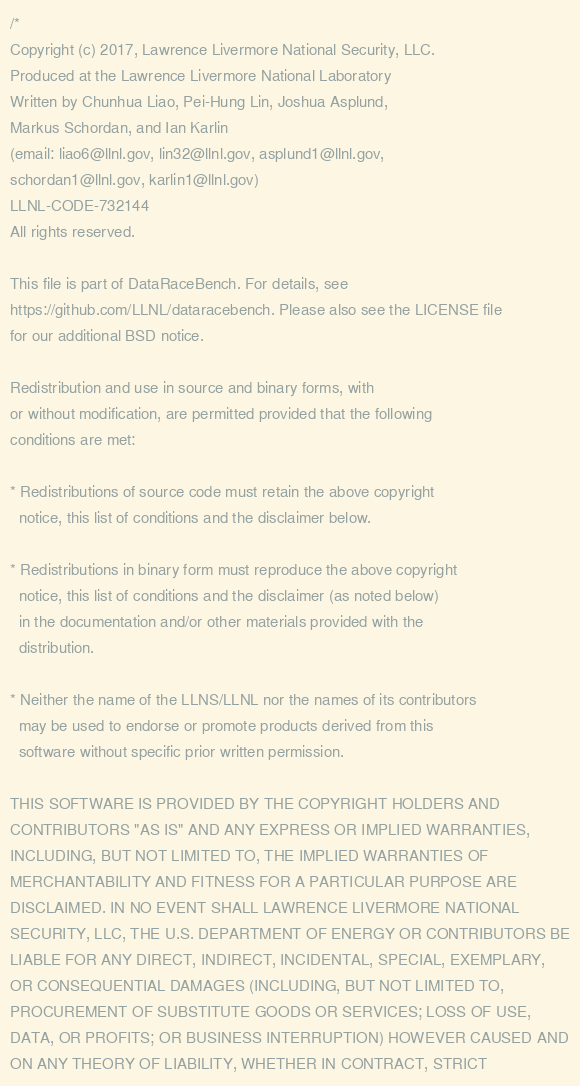<code> <loc_0><loc_0><loc_500><loc_500><_C_>/*
Copyright (c) 2017, Lawrence Livermore National Security, LLC.
Produced at the Lawrence Livermore National Laboratory
Written by Chunhua Liao, Pei-Hung Lin, Joshua Asplund,
Markus Schordan, and Ian Karlin
(email: liao6@llnl.gov, lin32@llnl.gov, asplund1@llnl.gov,
schordan1@llnl.gov, karlin1@llnl.gov)
LLNL-CODE-732144
All rights reserved.

This file is part of DataRaceBench. For details, see
https://github.com/LLNL/dataracebench. Please also see the LICENSE file
for our additional BSD notice.

Redistribution and use in source and binary forms, with
or without modification, are permitted provided that the following
conditions are met:

* Redistributions of source code must retain the above copyright
  notice, this list of conditions and the disclaimer below.

* Redistributions in binary form must reproduce the above copyright
  notice, this list of conditions and the disclaimer (as noted below)
  in the documentation and/or other materials provided with the
  distribution.

* Neither the name of the LLNS/LLNL nor the names of its contributors
  may be used to endorse or promote products derived from this
  software without specific prior written permission.

THIS SOFTWARE IS PROVIDED BY THE COPYRIGHT HOLDERS AND
CONTRIBUTORS "AS IS" AND ANY EXPRESS OR IMPLIED WARRANTIES,
INCLUDING, BUT NOT LIMITED TO, THE IMPLIED WARRANTIES OF
MERCHANTABILITY AND FITNESS FOR A PARTICULAR PURPOSE ARE
DISCLAIMED. IN NO EVENT SHALL LAWRENCE LIVERMORE NATIONAL
SECURITY, LLC, THE U.S. DEPARTMENT OF ENERGY OR CONTRIBUTORS BE
LIABLE FOR ANY DIRECT, INDIRECT, INCIDENTAL, SPECIAL, EXEMPLARY,
OR CONSEQUENTIAL DAMAGES (INCLUDING, BUT NOT LIMITED TO,
PROCUREMENT OF SUBSTITUTE GOODS OR SERVICES; LOSS OF USE,
DATA, OR PROFITS; OR BUSINESS INTERRUPTION) HOWEVER CAUSED AND
ON ANY THEORY OF LIABILITY, WHETHER IN CONTRACT, STRICT</code> 